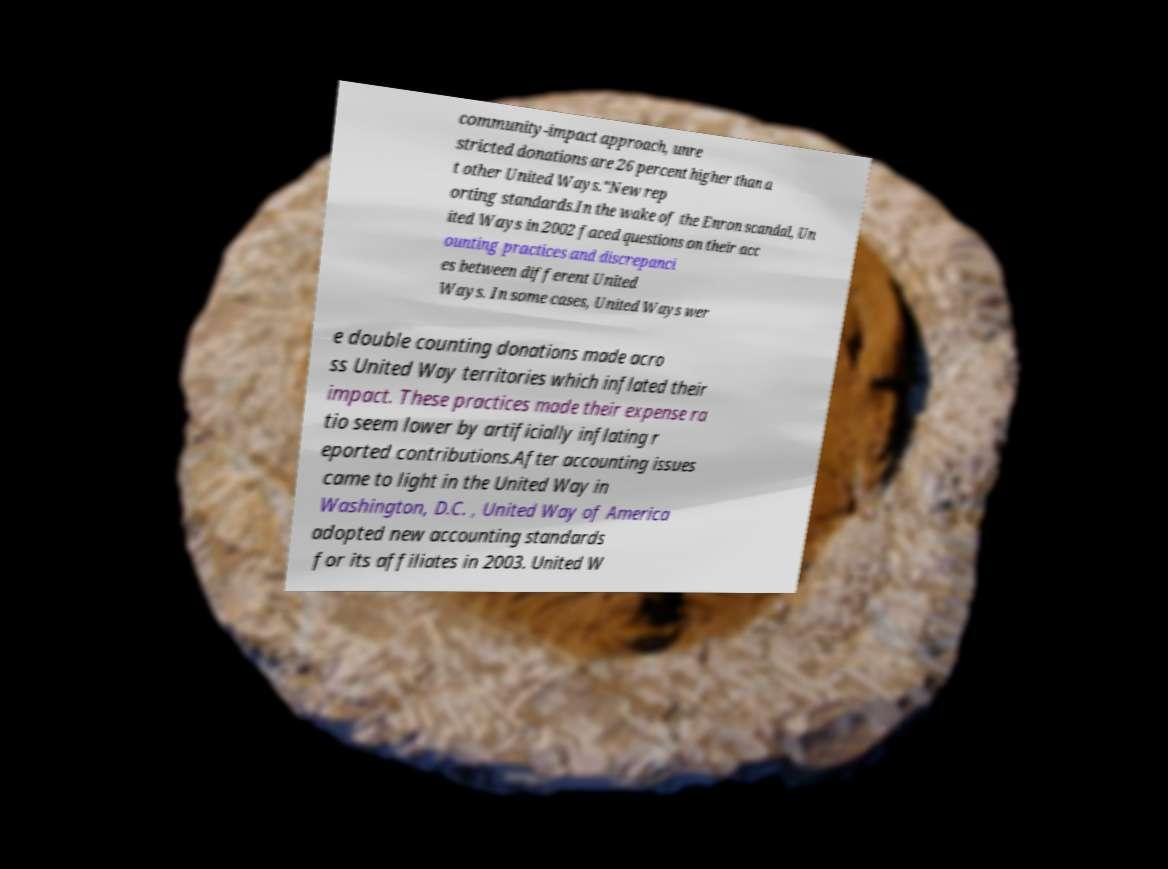There's text embedded in this image that I need extracted. Can you transcribe it verbatim? community-impact approach, unre stricted donations are 26 percent higher than a t other United Ways."New rep orting standards.In the wake of the Enron scandal, Un ited Ways in 2002 faced questions on their acc ounting practices and discrepanci es between different United Ways. In some cases, United Ways wer e double counting donations made acro ss United Way territories which inflated their impact. These practices made their expense ra tio seem lower by artificially inflating r eported contributions.After accounting issues came to light in the United Way in Washington, D.C. , United Way of America adopted new accounting standards for its affiliates in 2003. United W 